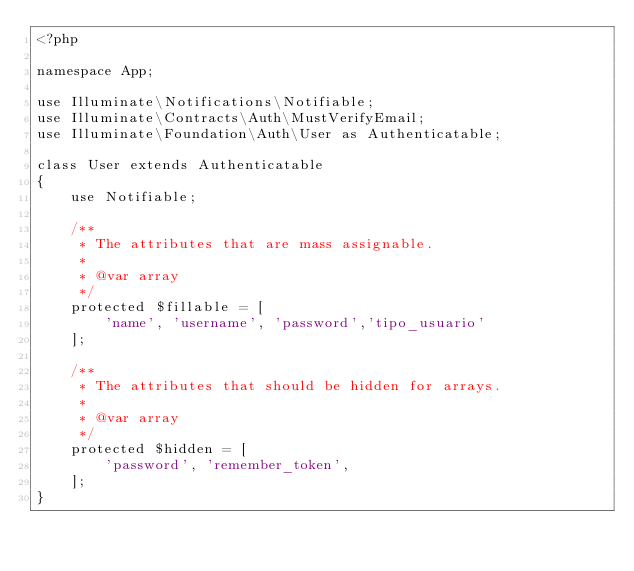<code> <loc_0><loc_0><loc_500><loc_500><_PHP_><?php

namespace App;

use Illuminate\Notifications\Notifiable;
use Illuminate\Contracts\Auth\MustVerifyEmail;
use Illuminate\Foundation\Auth\User as Authenticatable;

class User extends Authenticatable
{
    use Notifiable;

    /**
     * The attributes that are mass assignable.
     *
     * @var array
     */
    protected $fillable = [
        'name', 'username', 'password','tipo_usuario'
    ];

    /**
     * The attributes that should be hidden for arrays.
     *
     * @var array
     */
    protected $hidden = [
        'password', 'remember_token',
    ];
}
</code> 